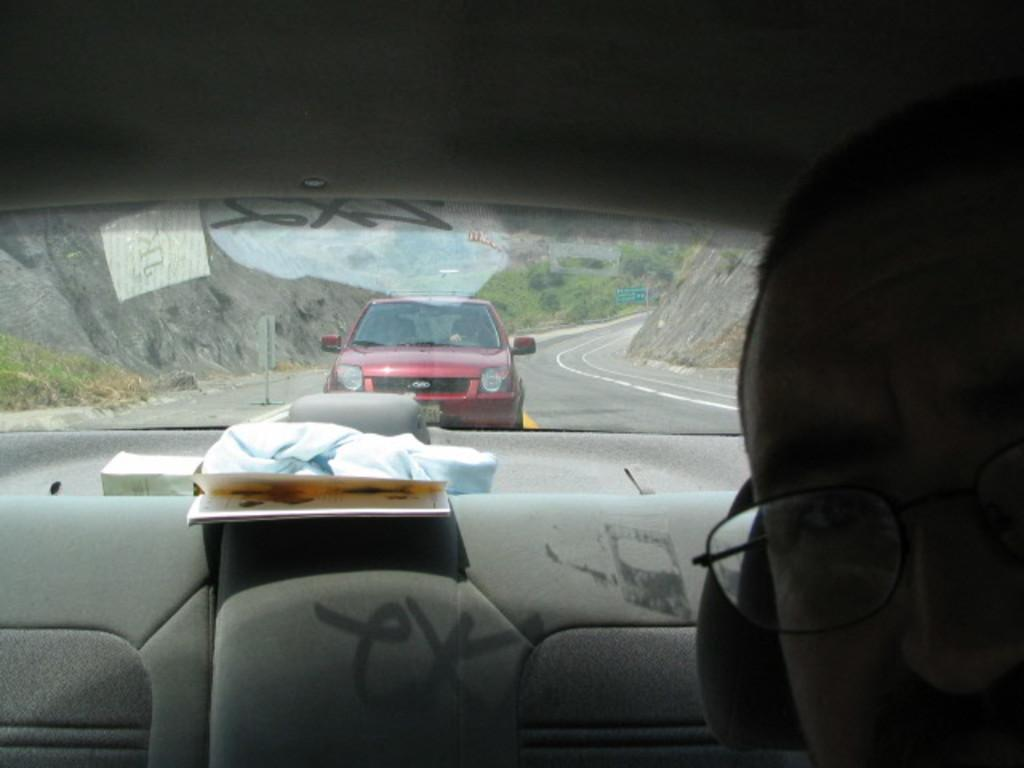What is the main object in the image? There is a vehicle mirror in the image. What can be seen through the vehicle mirror? Another vehicle is visible through the mirror. What type of natural elements are present in the image? There are rocks in the image. Can you see any walls in the image? There is no wall present in the image. Are there any snails visible in the image? There are no snails present in the image. 